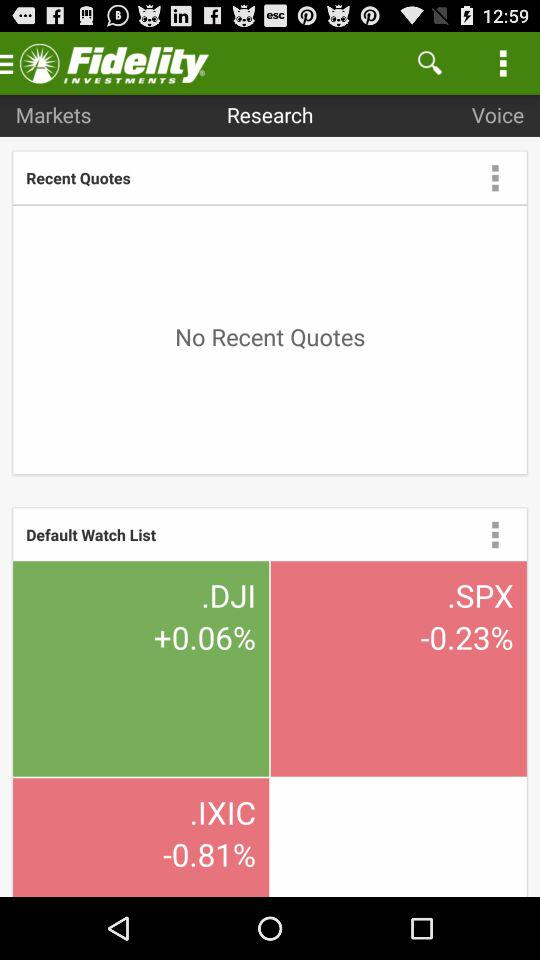Is there any quote? There is no quote. 